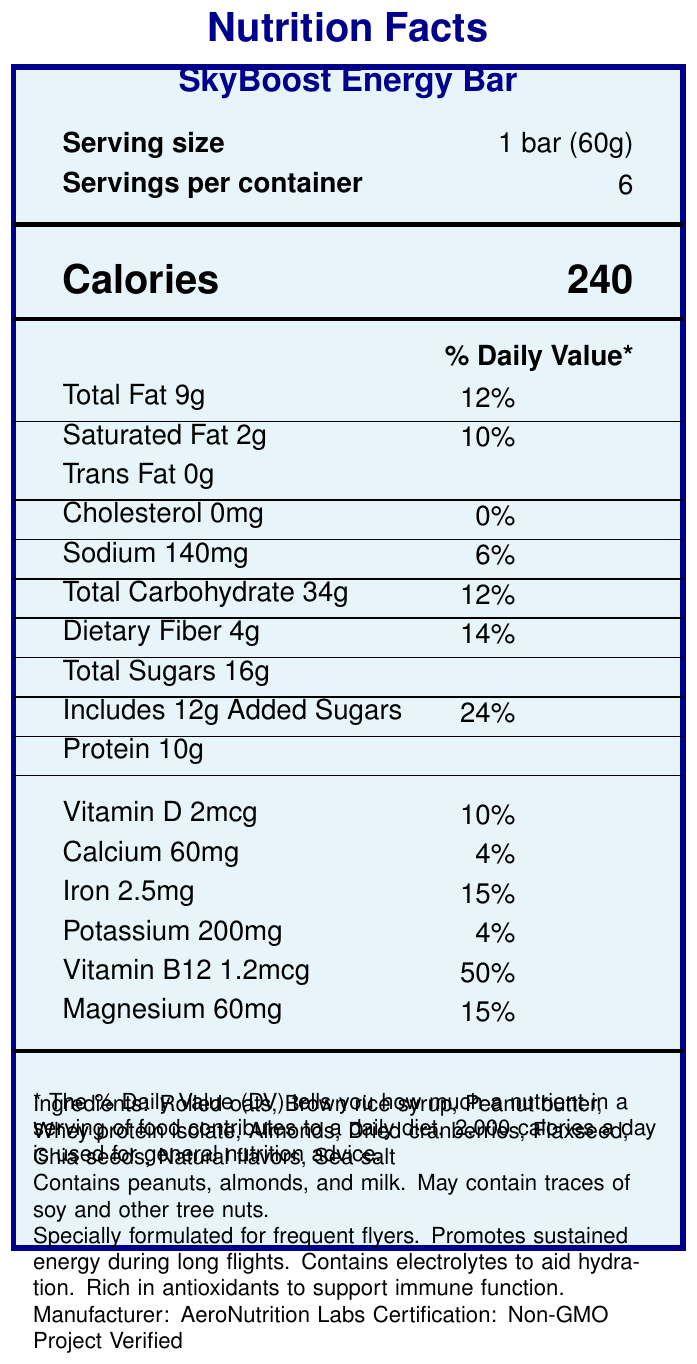What is the serving size for the SkyBoost Energy Bar? The serving size is explicitly mentioned next to the "Serving size" label.
Answer: 1 bar (60g) How many calories are there in one serving of the SkyBoost Energy Bar? The calorie content is directly listed near the "Calories" label.
Answer: 240 How much total fat does one SkyBoost Energy Bar contain? The total fat content is listed next to the "Total Fat" label.
Answer: 9g What percentage of the Daily Value (DV) of saturated fat is found in one serving? The percentage Daily Value of saturated fat is provided near the "Saturated Fat" label.
Answer: 10% Does the SkyBoost Energy Bar contain any trans fat? The "Trans Fat" label indicates "0g", meaning no trans fat is present.
Answer: No How much protein does one serving of the SkyBoost Energy Bar provide? The protein content is listed next to the "Protein" label.
Answer: 10g Which of the following allergens are present in the SkyBoost Energy Bar? A. Peanuts B. Almonds C. Milk D. All of the above The allergens section mentions that the product contains peanuts, almonds, and milk.
Answer: D. All of the above What is the manufacturer of the SkyBoost Energy Bar? A. Healthy Foods Inc. B. AeroNutrition Labs C. NutriSnack Enterprises The document specifies that the manufacturer is AeroNutrition Labs.
Answer: B. AeroNutrition Labs How much iron content is in one serving, and what is its percent Daily Value? The iron content is listed as 2.5mg, and the Daily Value is indicated as 15%.
Answer: 2.5mg and 15% Is the SkyBoost Energy Bar certified as Non-GMO? The certification section notes that the product is "Non-GMO Project Verified."
Answer: Yes Describe the main idea of the document. The main focus of the document is to present the nutritional content, servings, ingredients, allergens, manufacturer, and special attributes like Non-GMO certification.
Answer: The document provides detailed nutrition facts and additional information for the SkyBoost Energy Bar. What are the main ingredients of the SkyBoost Energy Bar? The main ingredients are listed in the ingredients section.
Answer: Rolled oats, Brown rice syrup, Peanut butter, Whey protein isolate, Almonds, Dried cranberries, Flaxseed, Chia seeds, Natural flavors, Sea salt What is the total amount of carbohydrates in one serving and the corresponding percent Daily Value? The document lists "Total Carbohydrate" as 34g with a 12% Daily Value.
Answer: 34g and 12% What additional benefits does the SkyBoost Energy Bar offer? The additional info section mentions these specific benefits.
Answer: Promotes sustained energy during long flights, contains electrolytes to aid hydration, rich in antioxidants to support immune function How much dietary fiber does the product contain per serving? The dietary fiber content is explicitly listed next to the "Dietary Fiber" label.
Answer: 4g Which vitamin has the highest percent Daily Value in the SkyBoost Energy Bar? A. Vitamin D B. Calcium C. Vitamin B12 The document lists Vitamin B12 with a 50% Daily Value, which is higher than those for Vitamin D (10%) and Calcium (4%).
Answer: C. Vitamin B12 How widely will the SkyBoost Energy Bar be available in various airline partners? The document does not provide any details regarding the distribution or availability of the product across airlines.
Answer: Not enough information 